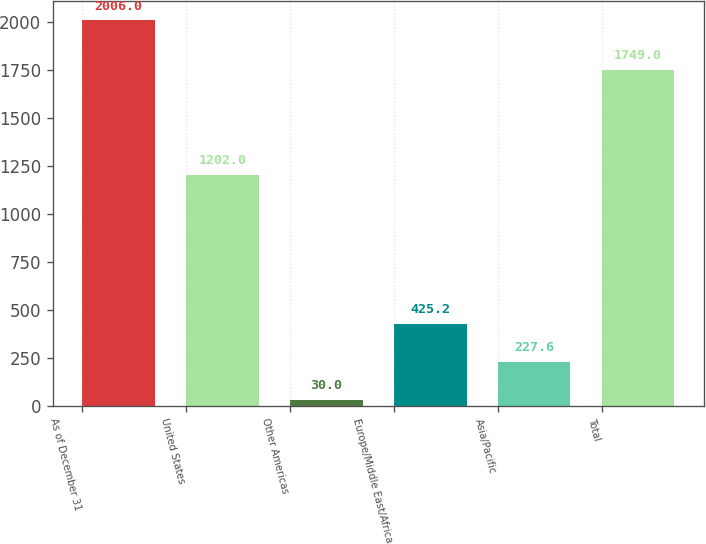<chart> <loc_0><loc_0><loc_500><loc_500><bar_chart><fcel>As of December 31<fcel>United States<fcel>Other Americas<fcel>Europe/Middle East/Africa<fcel>Asia/Pacific<fcel>Total<nl><fcel>2006<fcel>1202<fcel>30<fcel>425.2<fcel>227.6<fcel>1749<nl></chart> 